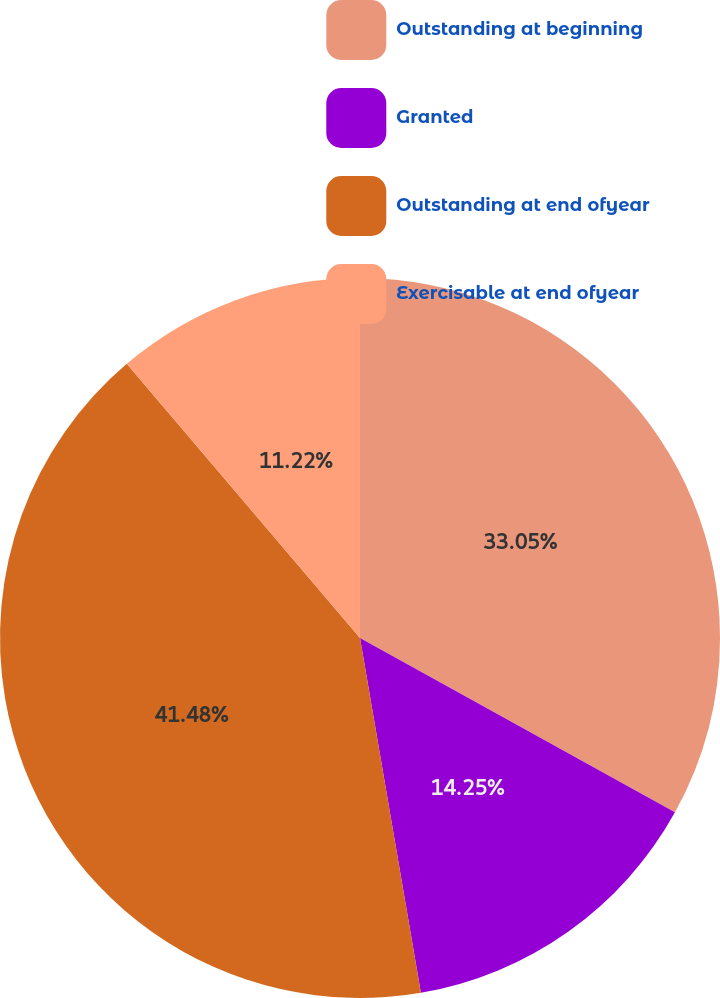<chart> <loc_0><loc_0><loc_500><loc_500><pie_chart><fcel>Outstanding at beginning<fcel>Granted<fcel>Outstanding at end ofyear<fcel>Exercisable at end ofyear<nl><fcel>33.05%<fcel>14.25%<fcel>41.49%<fcel>11.22%<nl></chart> 